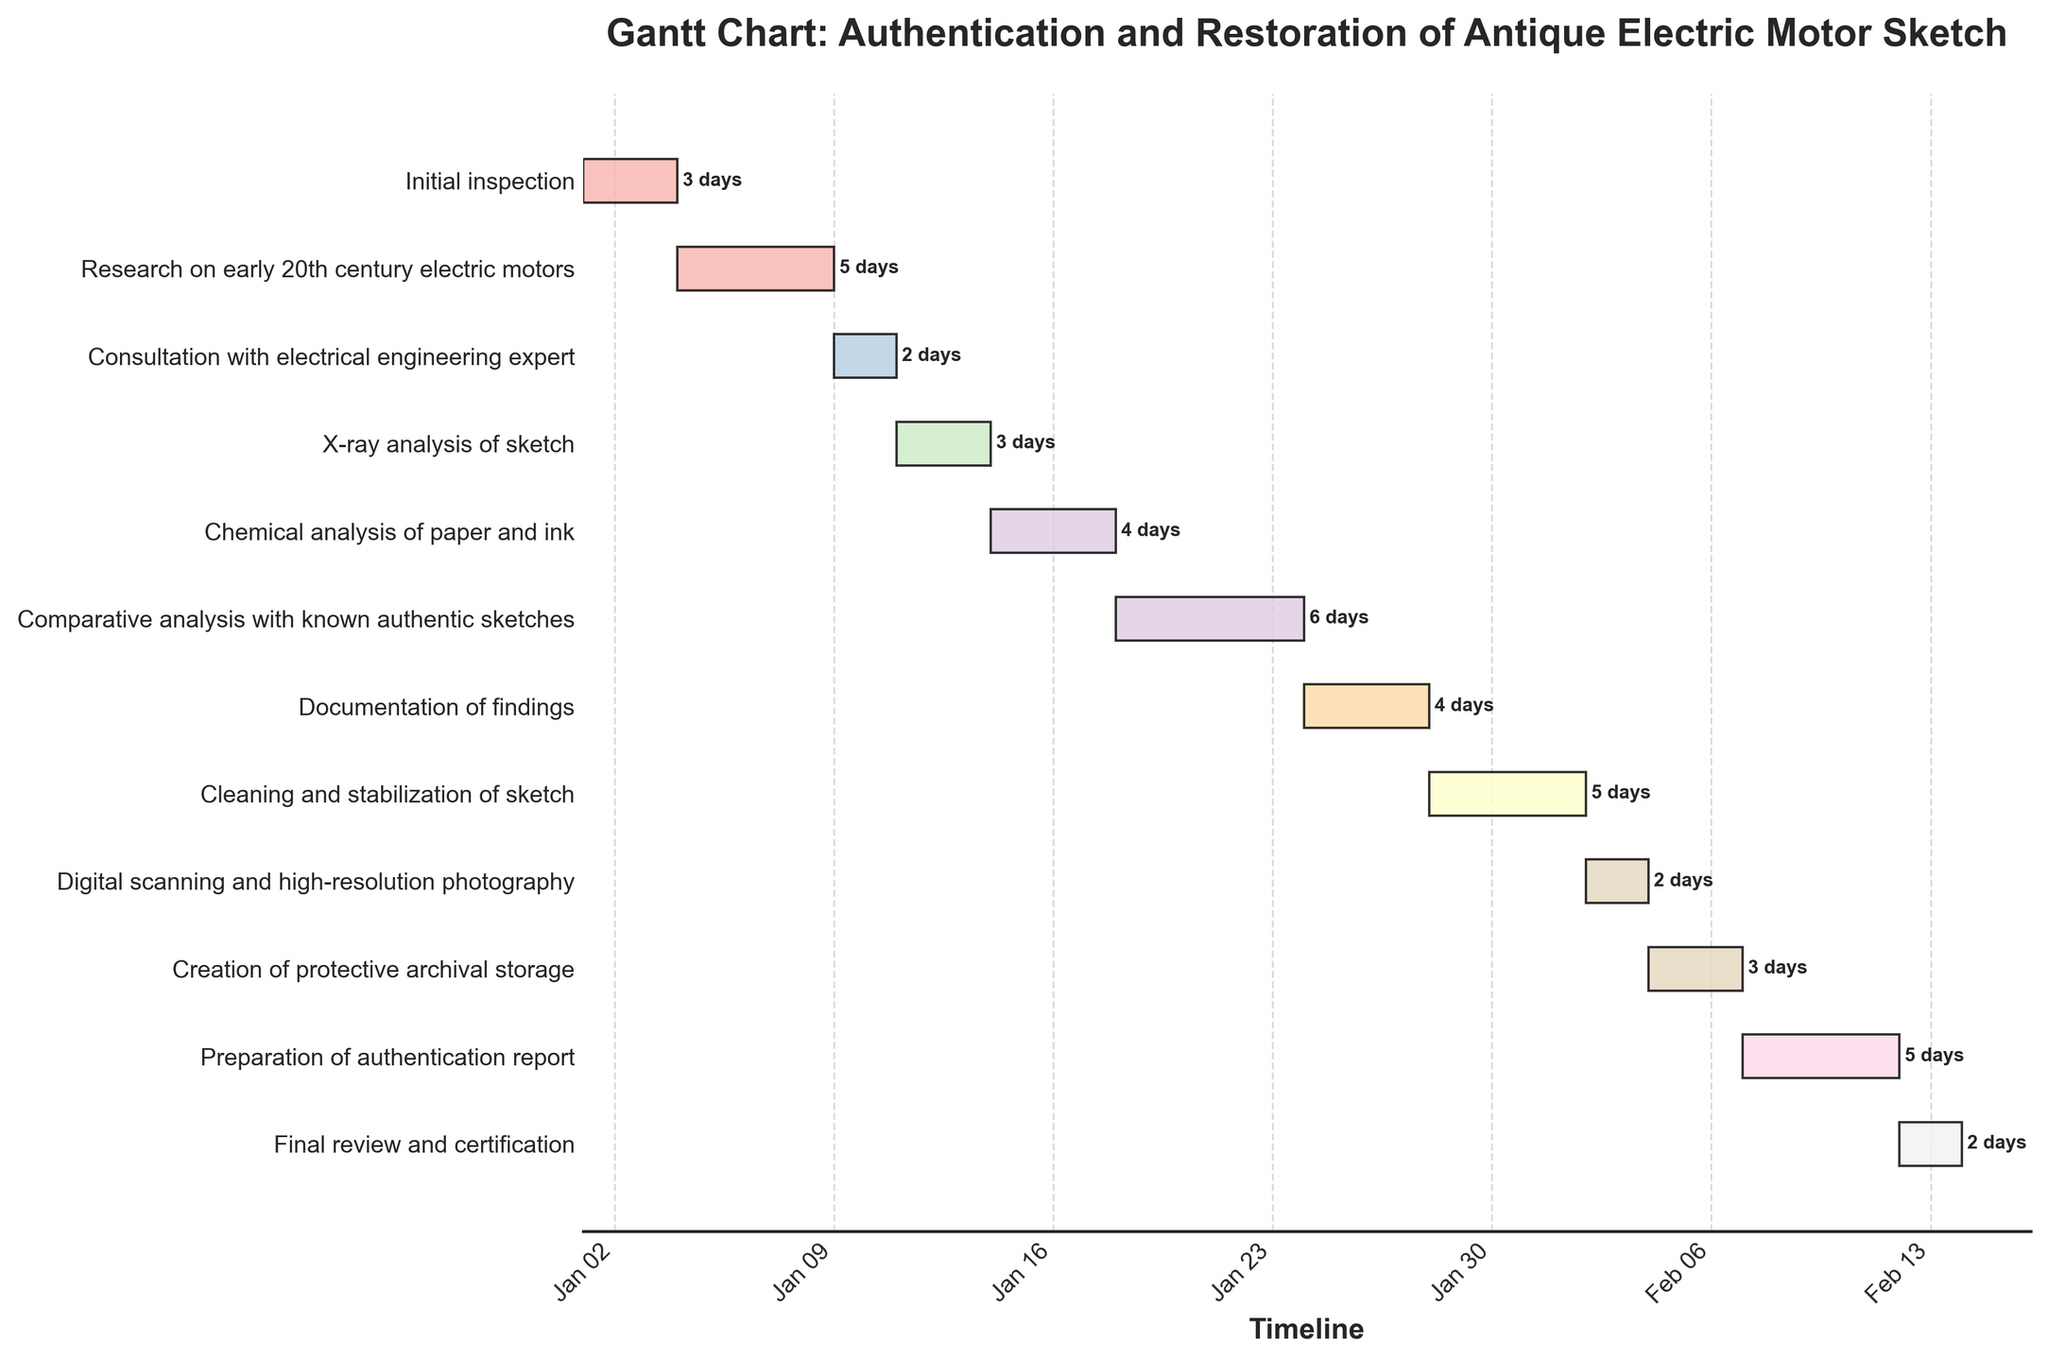What is the title of the Gantt Chart? The title is usually placed at the top of the chart, in a larger and bolder font than other text elements. According to the provided data and common conventions for Gantt charts, the title should be clearly visible at the top.
Answer: Authentication and Restoration of Antique Electric Motor Sketch When does the task "Digital scanning and high-resolution photography" start and for how long does it last? From the figure, locate the "Digital scanning and high-resolution photography" bar and look at its left edge to determine the start date, then check the length of the bar to determine the duration.
Answer: Starts at day 33 and lasts for 2 days What tasks are scheduled to start immediately after the "X-ray analysis of sketch"? Identify the end date of the "X-ray analysis of sketch" on the figure, and then find the tasks that start right after this date by looking for bars that start on the following day or immediately after.
Answer: Chemical analysis of paper and ink Which task has the longest duration? Compare the lengths of all the bars representing each task and identify the one that stretches the furthest horizontally. This task will have the longest duration.
Answer: Comparative analysis with known authentic sketches Are any tasks overlapping in the chart? Examine the horizontal bars for any instances where their timelines overlap. Overlapping bars visually indicate overlapping tasks.
Answer: No, tasks are sequential What is the total duration from the start of "Initial inspection" to the end of "Final review and certification"? Identify the start date of the "Initial inspection" and the end date of the "Final review and certification" from the chart. Calculate the difference in days between these two dates.
Answer: 45 days Which task comes immediately before "Documentation of findings"? Find the "Documentation of findings" bar, and determine which task ends right before this task begins by examining the task bars immediately adjacent to it.
Answer: Comparative analysis with known authentic sketches How many tasks are listed in this chart? Count the total number of bars (tasks) presented in the chart to determine how many tasks are involved.
Answer: 12 tasks What is the combined duration of "Research on early 20th century electric motors" and "Consultation with electrical engineering expert"? Find the durations of both tasks from the figure and add them together. "Research on early 20th century electric motors" lasts 5 days and "Consultation with electrical engineering expert" lasts 2 days.
Answer: 7 days Which tasks directly contribute to the preparation for the "Preparation of authentication report"? Identify tasks that precede the "Preparation of authentication report" and may provide necessary information or prerequisites for it by following the logical flow of the chart.
Answer: Creation of protective archival storage, Digital scanning and high-resolution photography 